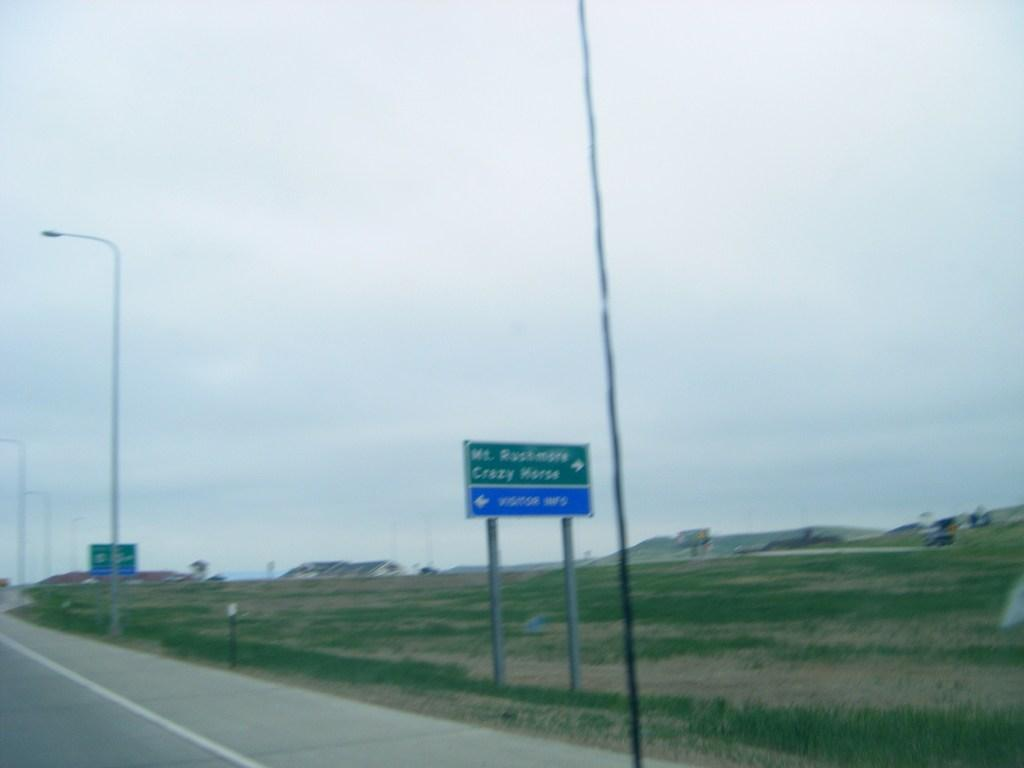What type of surface can be seen in the image? There is a road in the image. What structures are present alongside the road? There are poles and direction boards in the image. What type of vegetation is visible in the image? There is grass in the image. What geographical feature can be seen in the background of the image? There are mountains in the image. What is the condition of the sky in the image? The sky is clear in the image. How many kittens are playing with an orange on the road in the image? There are no kittens or oranges present in the image. 